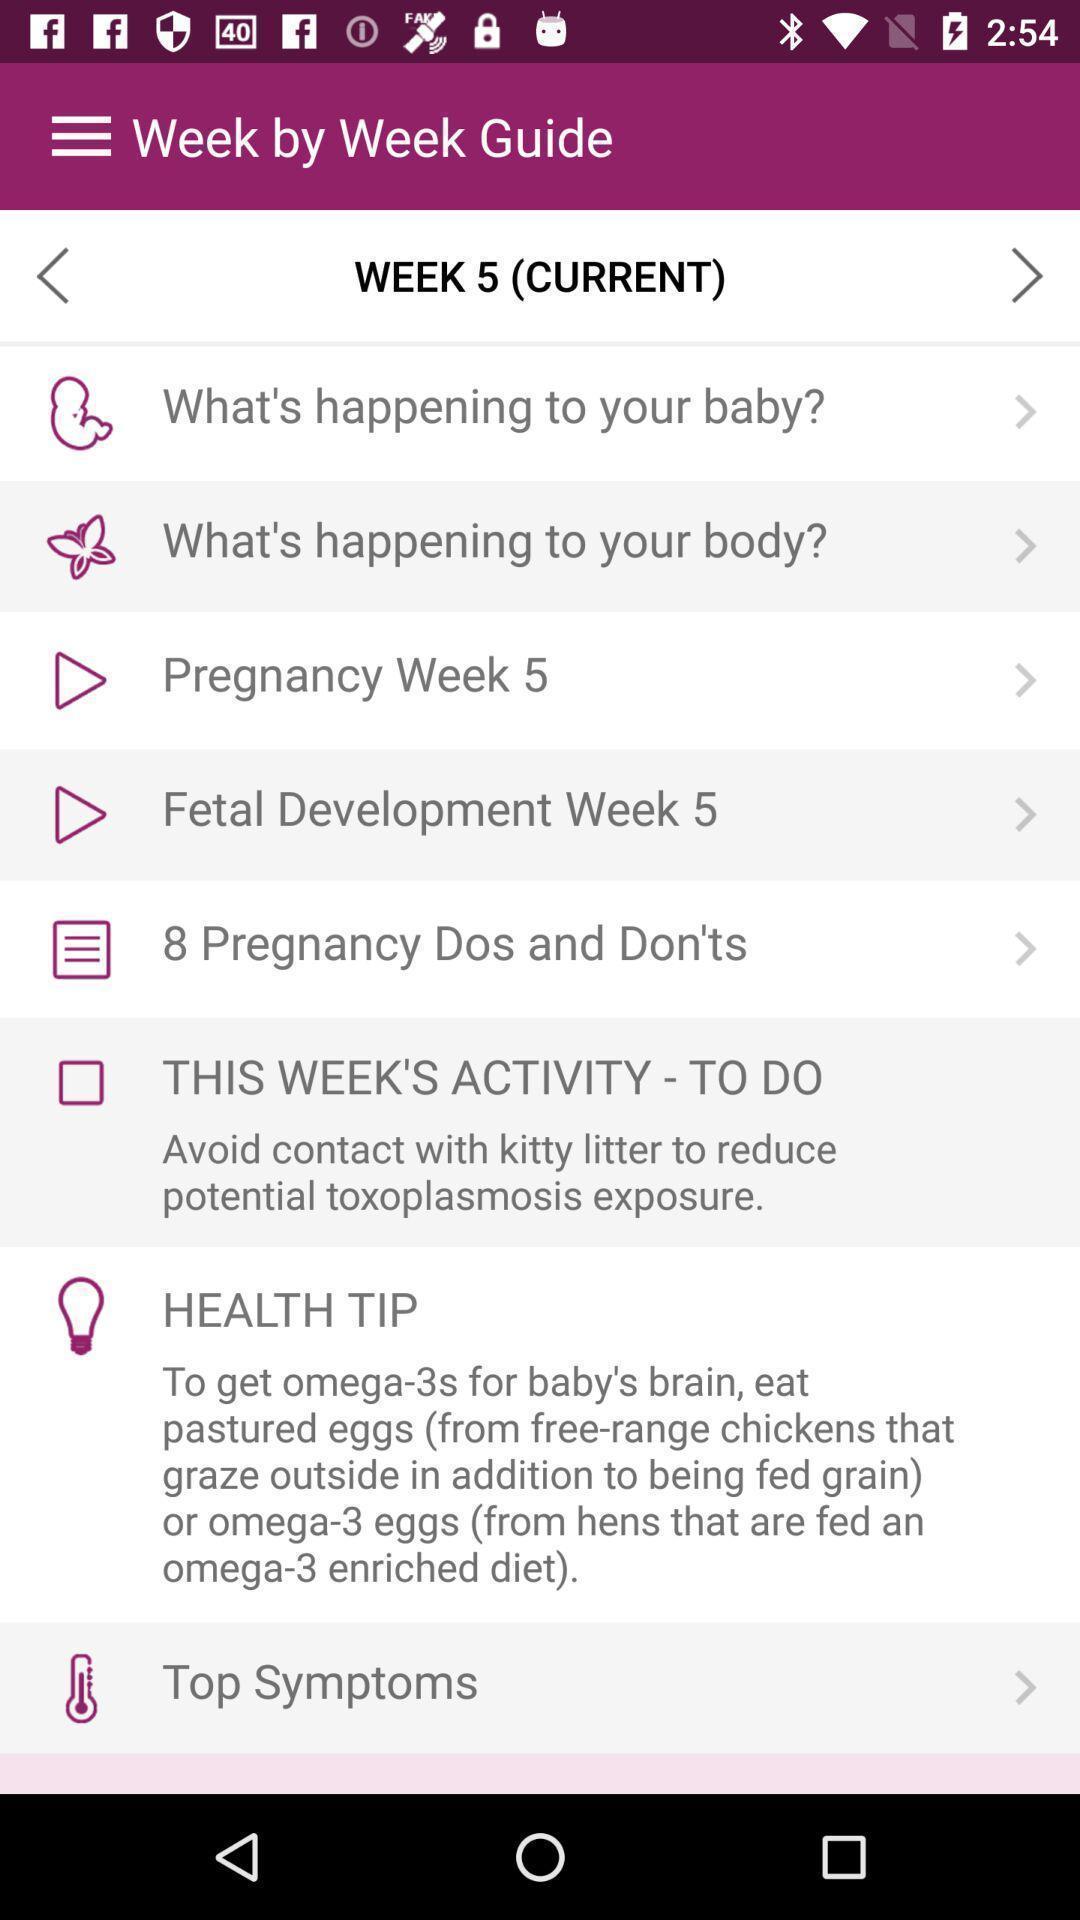Provide a textual representation of this image. Screen shows week guide details in a health application. 